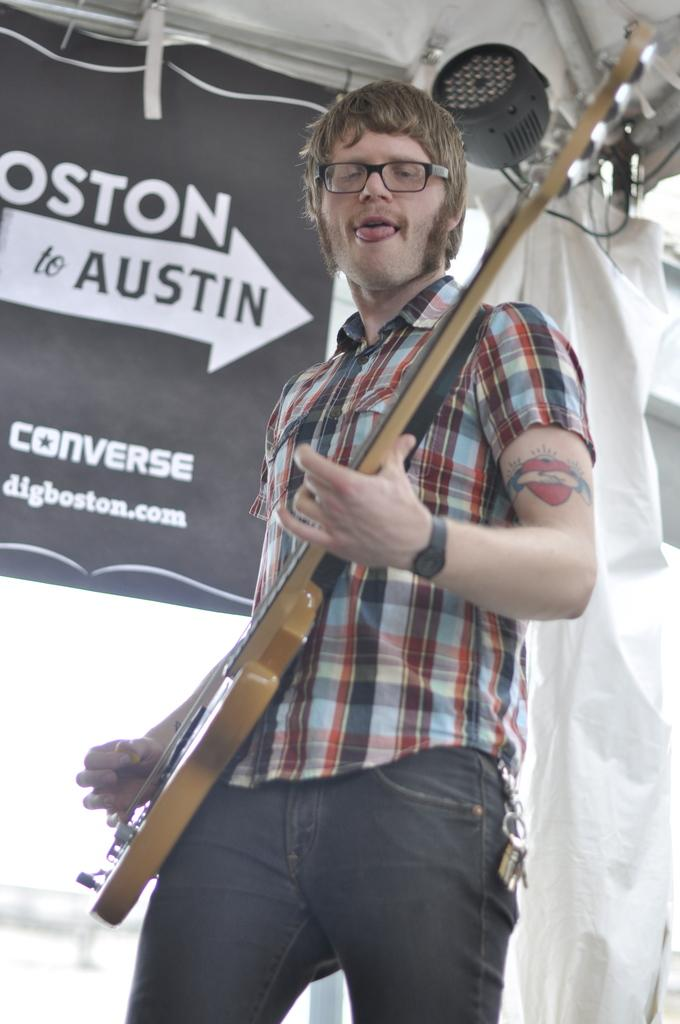What is the person in the image doing? The person is standing and playing guitar. Can you describe any distinguishing features of the person? The person has a tattoo on their hand. What else can be seen in the image besides the person playing guitar? There is a banner and a light in the image. What type of ring can be seen on the person's finger in the image? There is no ring visible on the person's finger in the image. How does the person's playing of the guitar make you feel? The image does not convey any feelings or emotions, as it is a still image. 